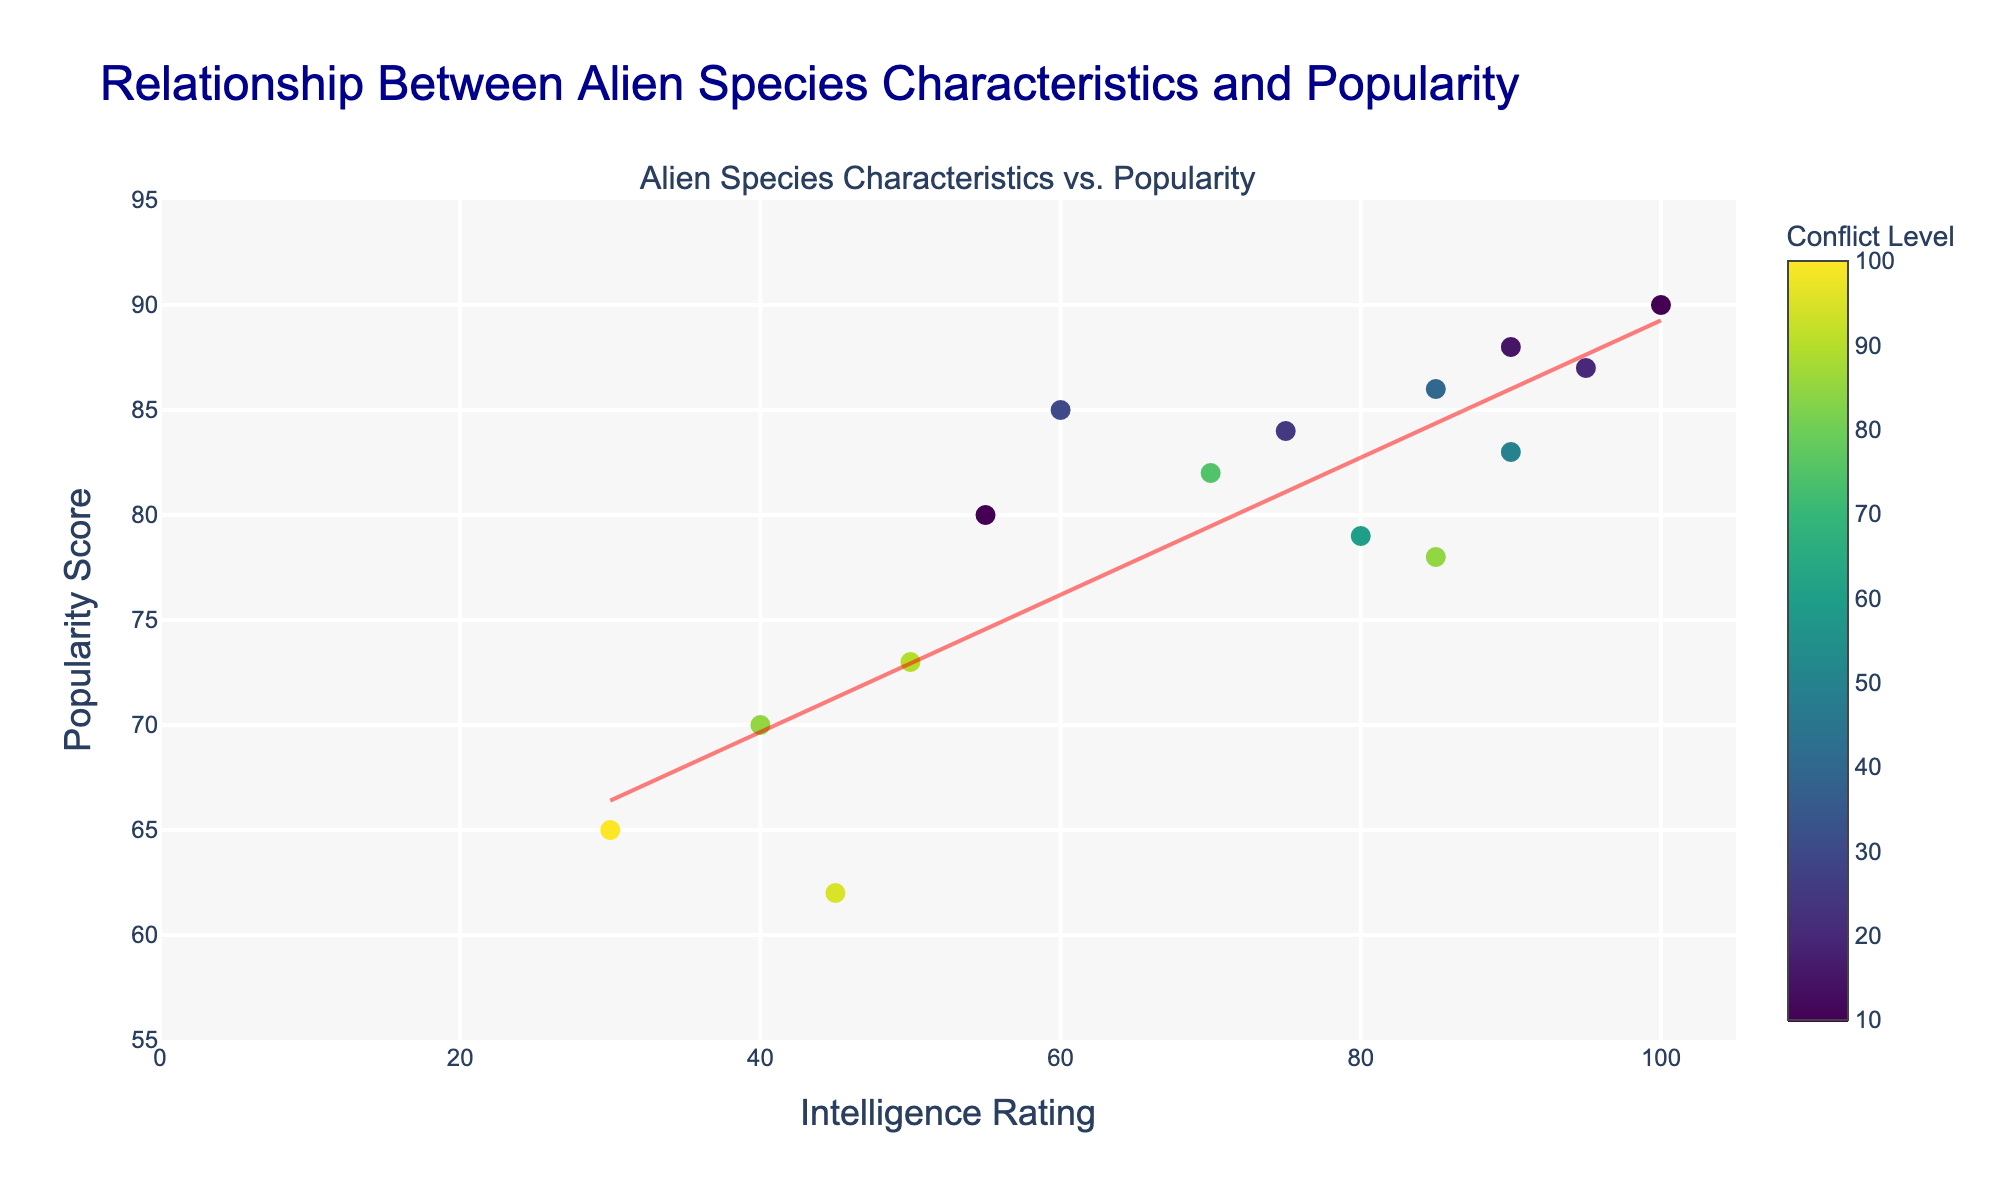What is the title of the figure? The title of the figure is placed at the top and it reads 'Relationship Between Alien Species Characteristics and Popularity'. By examining the textual element at the top center of the chart, the title can be easily identified.
Answer: Relationship Between Alien Species Characteristics and Popularity How many alien species are included in the plot? The number of data points, each representing an alien species, can be counted directly as there is one point for each species on the scatter plot.
Answer: 15 Which two alien species have the highest conflict levels, based on color shading? By observing the color scale on the scatter plot, the two species with the darkest colors (representing high conflict levels) on the Viridis scale are "Xenomorphs" and "Daleks".
Answer: Xenomorphs and Daleks Is there a general trend between intelligence rating and popularity score? By observing the trend line overlaid on the scatter plot, which slopes upwards, it can be inferred that there is a general positive trend between intelligence rating and popularity score.
Answer: Positive trend Which alien species has the highest popularity score and what are its intelligence and conflict levels? The popularity score is highest where the data point reaches the top of the y-axis. Hovering over this point in the visual shows that "Kryptonians" holds this position. The intelligence rating for Kryptonians is 100 and conflict level is 10, as indicated in the hover text.
Answer: Kryptonians with intelligence 100 and conflict 10 Do alien species with low intelligence ratings tend to be less popular? By inspecting the left side of the scatter plot with lower intelligence ratings (lower x-values) and their corresponding y-values (popularity scores), it can be observed if these points are generally towards the bottom of the y-axis.
Answer: Generally yes What is the average popularity score of alien species with an intelligence rating greater than 80? Identify the points with intelligence ratings greater than 80: Vulcans, Asari, Kryptonians, Yoda's Species, Time Lords, Borg. Sum their popularity scores: 87 + 83 + 90 + 88 + 86 + 78 = 512. There are 6 species, so the average is 512/6.
Answer: 85.33 Which alien species shows a remarkable popularity despite having a relatively low conflict level and what does their data indicate? Examining the plot, "E.T. Species" has a relatively low conflict level and still shows a high popularity. Hovering over the point shows: Intelligence = 55, Popularity = 80, Conflict = 10.
Answer: E.T. Species: Intelligence 55, Popularity 80, Conflict 10 What is the popularity difference between the species with the highest and lowest intelligence ratings? "Kryptonians" has the highest intelligence at 100 with a popularity of 90, while "Xenomorphs" have the lowest intelligence at 30 with a popularity of 65. The difference is 90 - 65.
Answer: 25 Among species with conflict levels above 80, which one is the least popular? Filter the points by conflict level above 80. These species are Borg, Hutt, Predators, Daleks, Xenomorphs. Among these, "Daleks" has the lowest popularity score of 62.
Answer: Daleks 